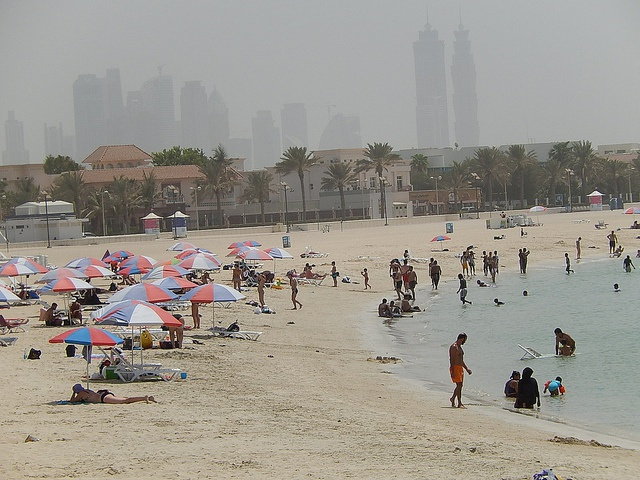Describe the objects in this image and their specific colors. I can see umbrella in darkgray, gray, and tan tones, people in darkgray, black, gray, and maroon tones, umbrella in darkgray, lightgray, gray, and lightpink tones, umbrella in darkgray, salmon, and gray tones, and people in darkgray, maroon, black, and gray tones in this image. 